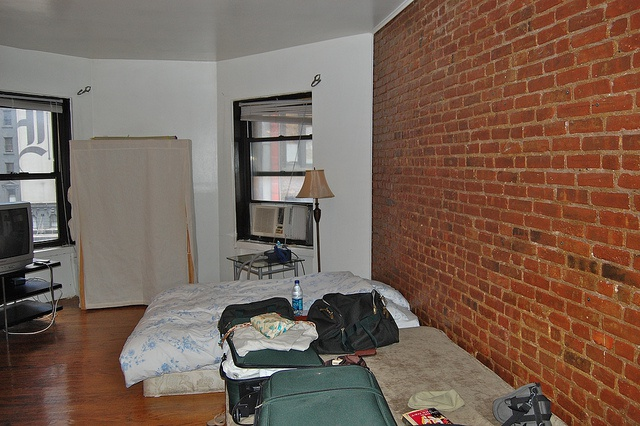Describe the objects in this image and their specific colors. I can see bed in gray and darkgray tones, suitcase in gray, black, darkgray, and lightgray tones, suitcase in gray, teal, and black tones, handbag in gray, black, and darkgray tones, and tv in gray, black, and purple tones in this image. 